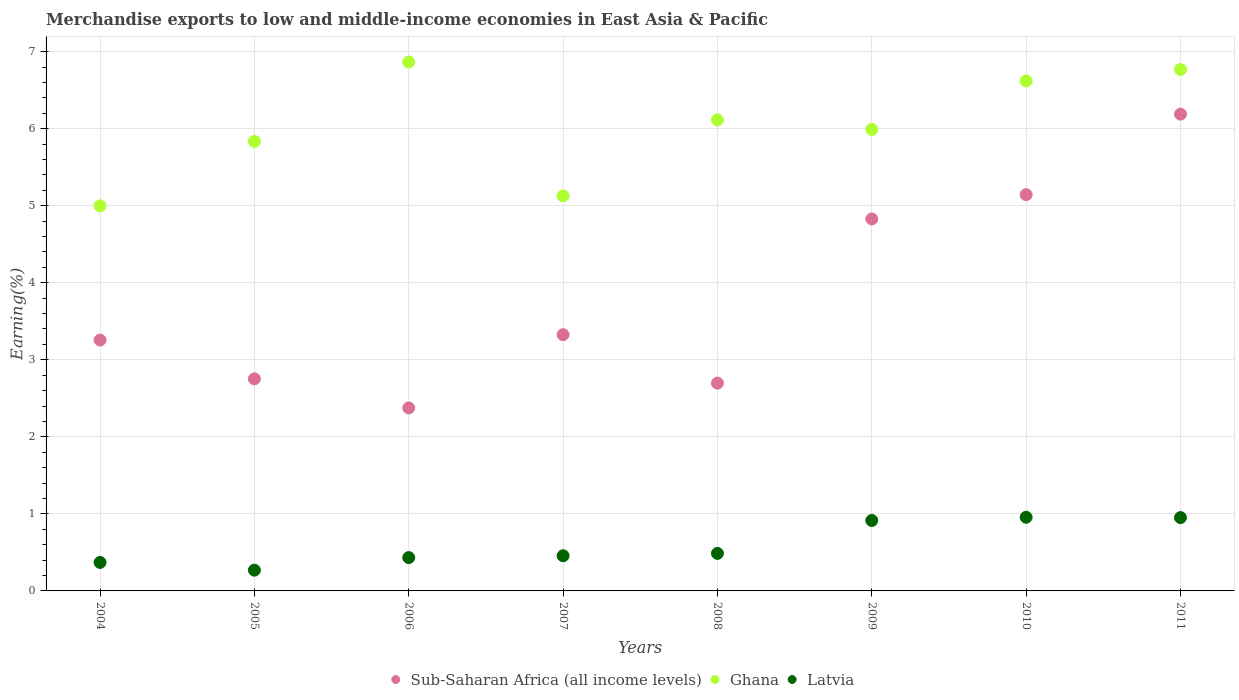What is the percentage of amount earned from merchandise exports in Latvia in 2010?
Offer a terse response. 0.96. Across all years, what is the maximum percentage of amount earned from merchandise exports in Sub-Saharan Africa (all income levels)?
Your answer should be very brief. 6.19. Across all years, what is the minimum percentage of amount earned from merchandise exports in Latvia?
Provide a succinct answer. 0.27. In which year was the percentage of amount earned from merchandise exports in Latvia maximum?
Ensure brevity in your answer.  2010. In which year was the percentage of amount earned from merchandise exports in Latvia minimum?
Make the answer very short. 2005. What is the total percentage of amount earned from merchandise exports in Ghana in the graph?
Provide a short and direct response. 48.32. What is the difference between the percentage of amount earned from merchandise exports in Latvia in 2004 and that in 2011?
Give a very brief answer. -0.58. What is the difference between the percentage of amount earned from merchandise exports in Latvia in 2005 and the percentage of amount earned from merchandise exports in Ghana in 2009?
Provide a succinct answer. -5.72. What is the average percentage of amount earned from merchandise exports in Sub-Saharan Africa (all income levels) per year?
Your answer should be compact. 3.82. In the year 2011, what is the difference between the percentage of amount earned from merchandise exports in Latvia and percentage of amount earned from merchandise exports in Ghana?
Make the answer very short. -5.82. What is the ratio of the percentage of amount earned from merchandise exports in Latvia in 2009 to that in 2010?
Offer a terse response. 0.96. What is the difference between the highest and the second highest percentage of amount earned from merchandise exports in Latvia?
Ensure brevity in your answer.  0. What is the difference between the highest and the lowest percentage of amount earned from merchandise exports in Sub-Saharan Africa (all income levels)?
Keep it short and to the point. 3.81. Is the sum of the percentage of amount earned from merchandise exports in Ghana in 2004 and 2005 greater than the maximum percentage of amount earned from merchandise exports in Sub-Saharan Africa (all income levels) across all years?
Provide a short and direct response. Yes. Is it the case that in every year, the sum of the percentage of amount earned from merchandise exports in Latvia and percentage of amount earned from merchandise exports in Ghana  is greater than the percentage of amount earned from merchandise exports in Sub-Saharan Africa (all income levels)?
Make the answer very short. Yes. Does the percentage of amount earned from merchandise exports in Latvia monotonically increase over the years?
Offer a terse response. No. Is the percentage of amount earned from merchandise exports in Ghana strictly greater than the percentage of amount earned from merchandise exports in Latvia over the years?
Give a very brief answer. Yes. How many dotlines are there?
Make the answer very short. 3. How many years are there in the graph?
Your answer should be very brief. 8. What is the difference between two consecutive major ticks on the Y-axis?
Offer a terse response. 1. Are the values on the major ticks of Y-axis written in scientific E-notation?
Your response must be concise. No. Does the graph contain any zero values?
Provide a short and direct response. No. Where does the legend appear in the graph?
Offer a very short reply. Bottom center. What is the title of the graph?
Ensure brevity in your answer.  Merchandise exports to low and middle-income economies in East Asia & Pacific. Does "Tajikistan" appear as one of the legend labels in the graph?
Provide a short and direct response. No. What is the label or title of the Y-axis?
Provide a short and direct response. Earning(%). What is the Earning(%) of Sub-Saharan Africa (all income levels) in 2004?
Give a very brief answer. 3.26. What is the Earning(%) in Ghana in 2004?
Your response must be concise. 5. What is the Earning(%) of Latvia in 2004?
Give a very brief answer. 0.37. What is the Earning(%) of Sub-Saharan Africa (all income levels) in 2005?
Give a very brief answer. 2.75. What is the Earning(%) of Ghana in 2005?
Provide a succinct answer. 5.83. What is the Earning(%) of Latvia in 2005?
Your answer should be very brief. 0.27. What is the Earning(%) in Sub-Saharan Africa (all income levels) in 2006?
Your response must be concise. 2.38. What is the Earning(%) in Ghana in 2006?
Keep it short and to the point. 6.87. What is the Earning(%) in Latvia in 2006?
Ensure brevity in your answer.  0.43. What is the Earning(%) in Sub-Saharan Africa (all income levels) in 2007?
Make the answer very short. 3.33. What is the Earning(%) in Ghana in 2007?
Provide a short and direct response. 5.13. What is the Earning(%) in Latvia in 2007?
Your response must be concise. 0.46. What is the Earning(%) in Sub-Saharan Africa (all income levels) in 2008?
Your answer should be compact. 2.7. What is the Earning(%) of Ghana in 2008?
Give a very brief answer. 6.12. What is the Earning(%) of Latvia in 2008?
Make the answer very short. 0.49. What is the Earning(%) in Sub-Saharan Africa (all income levels) in 2009?
Your answer should be very brief. 4.83. What is the Earning(%) of Ghana in 2009?
Your answer should be very brief. 5.99. What is the Earning(%) of Latvia in 2009?
Offer a very short reply. 0.91. What is the Earning(%) of Sub-Saharan Africa (all income levels) in 2010?
Your response must be concise. 5.14. What is the Earning(%) in Ghana in 2010?
Your answer should be very brief. 6.62. What is the Earning(%) in Latvia in 2010?
Your answer should be compact. 0.96. What is the Earning(%) of Sub-Saharan Africa (all income levels) in 2011?
Make the answer very short. 6.19. What is the Earning(%) of Ghana in 2011?
Your answer should be very brief. 6.77. What is the Earning(%) of Latvia in 2011?
Give a very brief answer. 0.95. Across all years, what is the maximum Earning(%) in Sub-Saharan Africa (all income levels)?
Provide a short and direct response. 6.19. Across all years, what is the maximum Earning(%) of Ghana?
Your answer should be compact. 6.87. Across all years, what is the maximum Earning(%) of Latvia?
Your answer should be compact. 0.96. Across all years, what is the minimum Earning(%) in Sub-Saharan Africa (all income levels)?
Provide a short and direct response. 2.38. Across all years, what is the minimum Earning(%) of Ghana?
Ensure brevity in your answer.  5. Across all years, what is the minimum Earning(%) in Latvia?
Keep it short and to the point. 0.27. What is the total Earning(%) of Sub-Saharan Africa (all income levels) in the graph?
Your response must be concise. 30.57. What is the total Earning(%) in Ghana in the graph?
Provide a succinct answer. 48.32. What is the total Earning(%) in Latvia in the graph?
Provide a succinct answer. 4.84. What is the difference between the Earning(%) of Sub-Saharan Africa (all income levels) in 2004 and that in 2005?
Provide a short and direct response. 0.5. What is the difference between the Earning(%) in Ghana in 2004 and that in 2005?
Offer a very short reply. -0.84. What is the difference between the Earning(%) in Latvia in 2004 and that in 2005?
Make the answer very short. 0.1. What is the difference between the Earning(%) in Sub-Saharan Africa (all income levels) in 2004 and that in 2006?
Your answer should be very brief. 0.88. What is the difference between the Earning(%) of Ghana in 2004 and that in 2006?
Give a very brief answer. -1.87. What is the difference between the Earning(%) in Latvia in 2004 and that in 2006?
Give a very brief answer. -0.06. What is the difference between the Earning(%) of Sub-Saharan Africa (all income levels) in 2004 and that in 2007?
Provide a short and direct response. -0.07. What is the difference between the Earning(%) of Ghana in 2004 and that in 2007?
Provide a succinct answer. -0.13. What is the difference between the Earning(%) in Latvia in 2004 and that in 2007?
Offer a terse response. -0.09. What is the difference between the Earning(%) of Sub-Saharan Africa (all income levels) in 2004 and that in 2008?
Your answer should be compact. 0.56. What is the difference between the Earning(%) in Ghana in 2004 and that in 2008?
Provide a succinct answer. -1.12. What is the difference between the Earning(%) of Latvia in 2004 and that in 2008?
Offer a terse response. -0.12. What is the difference between the Earning(%) of Sub-Saharan Africa (all income levels) in 2004 and that in 2009?
Your response must be concise. -1.57. What is the difference between the Earning(%) of Ghana in 2004 and that in 2009?
Your answer should be compact. -0.99. What is the difference between the Earning(%) of Latvia in 2004 and that in 2009?
Ensure brevity in your answer.  -0.54. What is the difference between the Earning(%) of Sub-Saharan Africa (all income levels) in 2004 and that in 2010?
Provide a succinct answer. -1.89. What is the difference between the Earning(%) in Ghana in 2004 and that in 2010?
Provide a succinct answer. -1.62. What is the difference between the Earning(%) in Latvia in 2004 and that in 2010?
Give a very brief answer. -0.59. What is the difference between the Earning(%) in Sub-Saharan Africa (all income levels) in 2004 and that in 2011?
Provide a short and direct response. -2.93. What is the difference between the Earning(%) in Ghana in 2004 and that in 2011?
Your answer should be compact. -1.77. What is the difference between the Earning(%) in Latvia in 2004 and that in 2011?
Your answer should be compact. -0.58. What is the difference between the Earning(%) in Sub-Saharan Africa (all income levels) in 2005 and that in 2006?
Make the answer very short. 0.38. What is the difference between the Earning(%) of Ghana in 2005 and that in 2006?
Provide a succinct answer. -1.03. What is the difference between the Earning(%) in Latvia in 2005 and that in 2006?
Your answer should be compact. -0.16. What is the difference between the Earning(%) of Sub-Saharan Africa (all income levels) in 2005 and that in 2007?
Your response must be concise. -0.57. What is the difference between the Earning(%) of Ghana in 2005 and that in 2007?
Ensure brevity in your answer.  0.71. What is the difference between the Earning(%) of Latvia in 2005 and that in 2007?
Keep it short and to the point. -0.19. What is the difference between the Earning(%) of Sub-Saharan Africa (all income levels) in 2005 and that in 2008?
Give a very brief answer. 0.06. What is the difference between the Earning(%) in Ghana in 2005 and that in 2008?
Give a very brief answer. -0.28. What is the difference between the Earning(%) of Latvia in 2005 and that in 2008?
Offer a terse response. -0.22. What is the difference between the Earning(%) in Sub-Saharan Africa (all income levels) in 2005 and that in 2009?
Offer a terse response. -2.08. What is the difference between the Earning(%) in Ghana in 2005 and that in 2009?
Your answer should be very brief. -0.16. What is the difference between the Earning(%) of Latvia in 2005 and that in 2009?
Give a very brief answer. -0.65. What is the difference between the Earning(%) in Sub-Saharan Africa (all income levels) in 2005 and that in 2010?
Keep it short and to the point. -2.39. What is the difference between the Earning(%) of Ghana in 2005 and that in 2010?
Your answer should be compact. -0.79. What is the difference between the Earning(%) of Latvia in 2005 and that in 2010?
Provide a short and direct response. -0.69. What is the difference between the Earning(%) in Sub-Saharan Africa (all income levels) in 2005 and that in 2011?
Your response must be concise. -3.44. What is the difference between the Earning(%) in Ghana in 2005 and that in 2011?
Provide a succinct answer. -0.93. What is the difference between the Earning(%) in Latvia in 2005 and that in 2011?
Provide a succinct answer. -0.68. What is the difference between the Earning(%) of Sub-Saharan Africa (all income levels) in 2006 and that in 2007?
Provide a short and direct response. -0.95. What is the difference between the Earning(%) of Ghana in 2006 and that in 2007?
Offer a very short reply. 1.74. What is the difference between the Earning(%) of Latvia in 2006 and that in 2007?
Keep it short and to the point. -0.02. What is the difference between the Earning(%) in Sub-Saharan Africa (all income levels) in 2006 and that in 2008?
Your response must be concise. -0.32. What is the difference between the Earning(%) of Ghana in 2006 and that in 2008?
Provide a short and direct response. 0.75. What is the difference between the Earning(%) of Latvia in 2006 and that in 2008?
Keep it short and to the point. -0.05. What is the difference between the Earning(%) in Sub-Saharan Africa (all income levels) in 2006 and that in 2009?
Your response must be concise. -2.45. What is the difference between the Earning(%) in Ghana in 2006 and that in 2009?
Give a very brief answer. 0.88. What is the difference between the Earning(%) of Latvia in 2006 and that in 2009?
Offer a very short reply. -0.48. What is the difference between the Earning(%) in Sub-Saharan Africa (all income levels) in 2006 and that in 2010?
Give a very brief answer. -2.77. What is the difference between the Earning(%) of Ghana in 2006 and that in 2010?
Keep it short and to the point. 0.25. What is the difference between the Earning(%) of Latvia in 2006 and that in 2010?
Provide a short and direct response. -0.52. What is the difference between the Earning(%) in Sub-Saharan Africa (all income levels) in 2006 and that in 2011?
Offer a very short reply. -3.81. What is the difference between the Earning(%) of Ghana in 2006 and that in 2011?
Your answer should be very brief. 0.1. What is the difference between the Earning(%) in Latvia in 2006 and that in 2011?
Provide a short and direct response. -0.52. What is the difference between the Earning(%) in Sub-Saharan Africa (all income levels) in 2007 and that in 2008?
Give a very brief answer. 0.63. What is the difference between the Earning(%) in Ghana in 2007 and that in 2008?
Offer a terse response. -0.99. What is the difference between the Earning(%) of Latvia in 2007 and that in 2008?
Your response must be concise. -0.03. What is the difference between the Earning(%) in Sub-Saharan Africa (all income levels) in 2007 and that in 2009?
Your response must be concise. -1.5. What is the difference between the Earning(%) in Ghana in 2007 and that in 2009?
Your answer should be compact. -0.86. What is the difference between the Earning(%) in Latvia in 2007 and that in 2009?
Offer a very short reply. -0.46. What is the difference between the Earning(%) of Sub-Saharan Africa (all income levels) in 2007 and that in 2010?
Your answer should be compact. -1.82. What is the difference between the Earning(%) in Ghana in 2007 and that in 2010?
Provide a short and direct response. -1.49. What is the difference between the Earning(%) in Latvia in 2007 and that in 2010?
Your answer should be compact. -0.5. What is the difference between the Earning(%) in Sub-Saharan Africa (all income levels) in 2007 and that in 2011?
Ensure brevity in your answer.  -2.86. What is the difference between the Earning(%) in Ghana in 2007 and that in 2011?
Keep it short and to the point. -1.64. What is the difference between the Earning(%) in Latvia in 2007 and that in 2011?
Keep it short and to the point. -0.5. What is the difference between the Earning(%) in Sub-Saharan Africa (all income levels) in 2008 and that in 2009?
Provide a succinct answer. -2.13. What is the difference between the Earning(%) of Ghana in 2008 and that in 2009?
Your answer should be compact. 0.12. What is the difference between the Earning(%) in Latvia in 2008 and that in 2009?
Provide a short and direct response. -0.43. What is the difference between the Earning(%) of Sub-Saharan Africa (all income levels) in 2008 and that in 2010?
Ensure brevity in your answer.  -2.45. What is the difference between the Earning(%) in Ghana in 2008 and that in 2010?
Ensure brevity in your answer.  -0.5. What is the difference between the Earning(%) of Latvia in 2008 and that in 2010?
Keep it short and to the point. -0.47. What is the difference between the Earning(%) of Sub-Saharan Africa (all income levels) in 2008 and that in 2011?
Make the answer very short. -3.49. What is the difference between the Earning(%) of Ghana in 2008 and that in 2011?
Offer a very short reply. -0.65. What is the difference between the Earning(%) in Latvia in 2008 and that in 2011?
Offer a terse response. -0.46. What is the difference between the Earning(%) in Sub-Saharan Africa (all income levels) in 2009 and that in 2010?
Offer a terse response. -0.32. What is the difference between the Earning(%) of Ghana in 2009 and that in 2010?
Provide a short and direct response. -0.63. What is the difference between the Earning(%) in Latvia in 2009 and that in 2010?
Give a very brief answer. -0.04. What is the difference between the Earning(%) of Sub-Saharan Africa (all income levels) in 2009 and that in 2011?
Keep it short and to the point. -1.36. What is the difference between the Earning(%) of Ghana in 2009 and that in 2011?
Your response must be concise. -0.78. What is the difference between the Earning(%) in Latvia in 2009 and that in 2011?
Ensure brevity in your answer.  -0.04. What is the difference between the Earning(%) of Sub-Saharan Africa (all income levels) in 2010 and that in 2011?
Offer a terse response. -1.05. What is the difference between the Earning(%) in Ghana in 2010 and that in 2011?
Keep it short and to the point. -0.15. What is the difference between the Earning(%) in Latvia in 2010 and that in 2011?
Give a very brief answer. 0. What is the difference between the Earning(%) of Sub-Saharan Africa (all income levels) in 2004 and the Earning(%) of Ghana in 2005?
Provide a succinct answer. -2.58. What is the difference between the Earning(%) in Sub-Saharan Africa (all income levels) in 2004 and the Earning(%) in Latvia in 2005?
Your answer should be very brief. 2.99. What is the difference between the Earning(%) of Ghana in 2004 and the Earning(%) of Latvia in 2005?
Provide a succinct answer. 4.73. What is the difference between the Earning(%) in Sub-Saharan Africa (all income levels) in 2004 and the Earning(%) in Ghana in 2006?
Your response must be concise. -3.61. What is the difference between the Earning(%) in Sub-Saharan Africa (all income levels) in 2004 and the Earning(%) in Latvia in 2006?
Offer a very short reply. 2.82. What is the difference between the Earning(%) in Ghana in 2004 and the Earning(%) in Latvia in 2006?
Your answer should be very brief. 4.57. What is the difference between the Earning(%) of Sub-Saharan Africa (all income levels) in 2004 and the Earning(%) of Ghana in 2007?
Your answer should be compact. -1.87. What is the difference between the Earning(%) in Sub-Saharan Africa (all income levels) in 2004 and the Earning(%) in Latvia in 2007?
Your answer should be compact. 2.8. What is the difference between the Earning(%) in Ghana in 2004 and the Earning(%) in Latvia in 2007?
Your response must be concise. 4.54. What is the difference between the Earning(%) of Sub-Saharan Africa (all income levels) in 2004 and the Earning(%) of Ghana in 2008?
Your answer should be very brief. -2.86. What is the difference between the Earning(%) of Sub-Saharan Africa (all income levels) in 2004 and the Earning(%) of Latvia in 2008?
Give a very brief answer. 2.77. What is the difference between the Earning(%) in Ghana in 2004 and the Earning(%) in Latvia in 2008?
Offer a terse response. 4.51. What is the difference between the Earning(%) in Sub-Saharan Africa (all income levels) in 2004 and the Earning(%) in Ghana in 2009?
Your answer should be very brief. -2.73. What is the difference between the Earning(%) in Sub-Saharan Africa (all income levels) in 2004 and the Earning(%) in Latvia in 2009?
Your answer should be compact. 2.34. What is the difference between the Earning(%) of Ghana in 2004 and the Earning(%) of Latvia in 2009?
Make the answer very short. 4.08. What is the difference between the Earning(%) of Sub-Saharan Africa (all income levels) in 2004 and the Earning(%) of Ghana in 2010?
Ensure brevity in your answer.  -3.36. What is the difference between the Earning(%) in Sub-Saharan Africa (all income levels) in 2004 and the Earning(%) in Latvia in 2010?
Provide a succinct answer. 2.3. What is the difference between the Earning(%) in Ghana in 2004 and the Earning(%) in Latvia in 2010?
Your answer should be very brief. 4.04. What is the difference between the Earning(%) of Sub-Saharan Africa (all income levels) in 2004 and the Earning(%) of Ghana in 2011?
Your response must be concise. -3.51. What is the difference between the Earning(%) in Sub-Saharan Africa (all income levels) in 2004 and the Earning(%) in Latvia in 2011?
Your answer should be compact. 2.3. What is the difference between the Earning(%) of Ghana in 2004 and the Earning(%) of Latvia in 2011?
Make the answer very short. 4.05. What is the difference between the Earning(%) of Sub-Saharan Africa (all income levels) in 2005 and the Earning(%) of Ghana in 2006?
Provide a short and direct response. -4.11. What is the difference between the Earning(%) of Sub-Saharan Africa (all income levels) in 2005 and the Earning(%) of Latvia in 2006?
Ensure brevity in your answer.  2.32. What is the difference between the Earning(%) of Ghana in 2005 and the Earning(%) of Latvia in 2006?
Your answer should be very brief. 5.4. What is the difference between the Earning(%) of Sub-Saharan Africa (all income levels) in 2005 and the Earning(%) of Ghana in 2007?
Provide a short and direct response. -2.37. What is the difference between the Earning(%) in Sub-Saharan Africa (all income levels) in 2005 and the Earning(%) in Latvia in 2007?
Offer a very short reply. 2.3. What is the difference between the Earning(%) in Ghana in 2005 and the Earning(%) in Latvia in 2007?
Ensure brevity in your answer.  5.38. What is the difference between the Earning(%) of Sub-Saharan Africa (all income levels) in 2005 and the Earning(%) of Ghana in 2008?
Your answer should be very brief. -3.36. What is the difference between the Earning(%) in Sub-Saharan Africa (all income levels) in 2005 and the Earning(%) in Latvia in 2008?
Make the answer very short. 2.27. What is the difference between the Earning(%) in Ghana in 2005 and the Earning(%) in Latvia in 2008?
Give a very brief answer. 5.35. What is the difference between the Earning(%) of Sub-Saharan Africa (all income levels) in 2005 and the Earning(%) of Ghana in 2009?
Offer a very short reply. -3.24. What is the difference between the Earning(%) of Sub-Saharan Africa (all income levels) in 2005 and the Earning(%) of Latvia in 2009?
Provide a short and direct response. 1.84. What is the difference between the Earning(%) of Ghana in 2005 and the Earning(%) of Latvia in 2009?
Offer a terse response. 4.92. What is the difference between the Earning(%) in Sub-Saharan Africa (all income levels) in 2005 and the Earning(%) in Ghana in 2010?
Ensure brevity in your answer.  -3.87. What is the difference between the Earning(%) of Sub-Saharan Africa (all income levels) in 2005 and the Earning(%) of Latvia in 2010?
Provide a short and direct response. 1.8. What is the difference between the Earning(%) in Ghana in 2005 and the Earning(%) in Latvia in 2010?
Give a very brief answer. 4.88. What is the difference between the Earning(%) of Sub-Saharan Africa (all income levels) in 2005 and the Earning(%) of Ghana in 2011?
Provide a short and direct response. -4.01. What is the difference between the Earning(%) in Sub-Saharan Africa (all income levels) in 2005 and the Earning(%) in Latvia in 2011?
Offer a very short reply. 1.8. What is the difference between the Earning(%) in Ghana in 2005 and the Earning(%) in Latvia in 2011?
Provide a succinct answer. 4.88. What is the difference between the Earning(%) in Sub-Saharan Africa (all income levels) in 2006 and the Earning(%) in Ghana in 2007?
Your response must be concise. -2.75. What is the difference between the Earning(%) in Sub-Saharan Africa (all income levels) in 2006 and the Earning(%) in Latvia in 2007?
Provide a short and direct response. 1.92. What is the difference between the Earning(%) of Ghana in 2006 and the Earning(%) of Latvia in 2007?
Your answer should be compact. 6.41. What is the difference between the Earning(%) in Sub-Saharan Africa (all income levels) in 2006 and the Earning(%) in Ghana in 2008?
Your answer should be compact. -3.74. What is the difference between the Earning(%) of Sub-Saharan Africa (all income levels) in 2006 and the Earning(%) of Latvia in 2008?
Keep it short and to the point. 1.89. What is the difference between the Earning(%) of Ghana in 2006 and the Earning(%) of Latvia in 2008?
Your answer should be compact. 6.38. What is the difference between the Earning(%) in Sub-Saharan Africa (all income levels) in 2006 and the Earning(%) in Ghana in 2009?
Give a very brief answer. -3.62. What is the difference between the Earning(%) in Sub-Saharan Africa (all income levels) in 2006 and the Earning(%) in Latvia in 2009?
Make the answer very short. 1.46. What is the difference between the Earning(%) in Ghana in 2006 and the Earning(%) in Latvia in 2009?
Your answer should be very brief. 5.95. What is the difference between the Earning(%) in Sub-Saharan Africa (all income levels) in 2006 and the Earning(%) in Ghana in 2010?
Offer a very short reply. -4.24. What is the difference between the Earning(%) in Sub-Saharan Africa (all income levels) in 2006 and the Earning(%) in Latvia in 2010?
Make the answer very short. 1.42. What is the difference between the Earning(%) of Ghana in 2006 and the Earning(%) of Latvia in 2010?
Keep it short and to the point. 5.91. What is the difference between the Earning(%) of Sub-Saharan Africa (all income levels) in 2006 and the Earning(%) of Ghana in 2011?
Ensure brevity in your answer.  -4.39. What is the difference between the Earning(%) in Sub-Saharan Africa (all income levels) in 2006 and the Earning(%) in Latvia in 2011?
Make the answer very short. 1.42. What is the difference between the Earning(%) in Ghana in 2006 and the Earning(%) in Latvia in 2011?
Your response must be concise. 5.91. What is the difference between the Earning(%) in Sub-Saharan Africa (all income levels) in 2007 and the Earning(%) in Ghana in 2008?
Your answer should be compact. -2.79. What is the difference between the Earning(%) in Sub-Saharan Africa (all income levels) in 2007 and the Earning(%) in Latvia in 2008?
Offer a very short reply. 2.84. What is the difference between the Earning(%) in Ghana in 2007 and the Earning(%) in Latvia in 2008?
Offer a terse response. 4.64. What is the difference between the Earning(%) of Sub-Saharan Africa (all income levels) in 2007 and the Earning(%) of Ghana in 2009?
Your response must be concise. -2.66. What is the difference between the Earning(%) of Sub-Saharan Africa (all income levels) in 2007 and the Earning(%) of Latvia in 2009?
Keep it short and to the point. 2.41. What is the difference between the Earning(%) in Ghana in 2007 and the Earning(%) in Latvia in 2009?
Your answer should be compact. 4.21. What is the difference between the Earning(%) in Sub-Saharan Africa (all income levels) in 2007 and the Earning(%) in Ghana in 2010?
Your answer should be compact. -3.29. What is the difference between the Earning(%) in Sub-Saharan Africa (all income levels) in 2007 and the Earning(%) in Latvia in 2010?
Your answer should be compact. 2.37. What is the difference between the Earning(%) of Ghana in 2007 and the Earning(%) of Latvia in 2010?
Ensure brevity in your answer.  4.17. What is the difference between the Earning(%) of Sub-Saharan Africa (all income levels) in 2007 and the Earning(%) of Ghana in 2011?
Offer a very short reply. -3.44. What is the difference between the Earning(%) of Sub-Saharan Africa (all income levels) in 2007 and the Earning(%) of Latvia in 2011?
Make the answer very short. 2.37. What is the difference between the Earning(%) in Ghana in 2007 and the Earning(%) in Latvia in 2011?
Give a very brief answer. 4.18. What is the difference between the Earning(%) of Sub-Saharan Africa (all income levels) in 2008 and the Earning(%) of Ghana in 2009?
Keep it short and to the point. -3.29. What is the difference between the Earning(%) in Sub-Saharan Africa (all income levels) in 2008 and the Earning(%) in Latvia in 2009?
Provide a short and direct response. 1.78. What is the difference between the Earning(%) in Ghana in 2008 and the Earning(%) in Latvia in 2009?
Your answer should be compact. 5.2. What is the difference between the Earning(%) in Sub-Saharan Africa (all income levels) in 2008 and the Earning(%) in Ghana in 2010?
Ensure brevity in your answer.  -3.92. What is the difference between the Earning(%) in Sub-Saharan Africa (all income levels) in 2008 and the Earning(%) in Latvia in 2010?
Your answer should be compact. 1.74. What is the difference between the Earning(%) in Ghana in 2008 and the Earning(%) in Latvia in 2010?
Your answer should be compact. 5.16. What is the difference between the Earning(%) in Sub-Saharan Africa (all income levels) in 2008 and the Earning(%) in Ghana in 2011?
Keep it short and to the point. -4.07. What is the difference between the Earning(%) in Sub-Saharan Africa (all income levels) in 2008 and the Earning(%) in Latvia in 2011?
Provide a short and direct response. 1.75. What is the difference between the Earning(%) of Ghana in 2008 and the Earning(%) of Latvia in 2011?
Keep it short and to the point. 5.16. What is the difference between the Earning(%) in Sub-Saharan Africa (all income levels) in 2009 and the Earning(%) in Ghana in 2010?
Your response must be concise. -1.79. What is the difference between the Earning(%) of Sub-Saharan Africa (all income levels) in 2009 and the Earning(%) of Latvia in 2010?
Give a very brief answer. 3.87. What is the difference between the Earning(%) of Ghana in 2009 and the Earning(%) of Latvia in 2010?
Offer a terse response. 5.03. What is the difference between the Earning(%) of Sub-Saharan Africa (all income levels) in 2009 and the Earning(%) of Ghana in 2011?
Keep it short and to the point. -1.94. What is the difference between the Earning(%) in Sub-Saharan Africa (all income levels) in 2009 and the Earning(%) in Latvia in 2011?
Provide a succinct answer. 3.88. What is the difference between the Earning(%) of Ghana in 2009 and the Earning(%) of Latvia in 2011?
Offer a terse response. 5.04. What is the difference between the Earning(%) of Sub-Saharan Africa (all income levels) in 2010 and the Earning(%) of Ghana in 2011?
Your response must be concise. -1.62. What is the difference between the Earning(%) in Sub-Saharan Africa (all income levels) in 2010 and the Earning(%) in Latvia in 2011?
Provide a succinct answer. 4.19. What is the difference between the Earning(%) of Ghana in 2010 and the Earning(%) of Latvia in 2011?
Your response must be concise. 5.67. What is the average Earning(%) of Sub-Saharan Africa (all income levels) per year?
Offer a terse response. 3.82. What is the average Earning(%) of Ghana per year?
Provide a succinct answer. 6.04. What is the average Earning(%) in Latvia per year?
Offer a very short reply. 0.6. In the year 2004, what is the difference between the Earning(%) in Sub-Saharan Africa (all income levels) and Earning(%) in Ghana?
Keep it short and to the point. -1.74. In the year 2004, what is the difference between the Earning(%) in Sub-Saharan Africa (all income levels) and Earning(%) in Latvia?
Offer a very short reply. 2.89. In the year 2004, what is the difference between the Earning(%) in Ghana and Earning(%) in Latvia?
Offer a very short reply. 4.63. In the year 2005, what is the difference between the Earning(%) in Sub-Saharan Africa (all income levels) and Earning(%) in Ghana?
Offer a terse response. -3.08. In the year 2005, what is the difference between the Earning(%) of Sub-Saharan Africa (all income levels) and Earning(%) of Latvia?
Keep it short and to the point. 2.48. In the year 2005, what is the difference between the Earning(%) of Ghana and Earning(%) of Latvia?
Give a very brief answer. 5.57. In the year 2006, what is the difference between the Earning(%) of Sub-Saharan Africa (all income levels) and Earning(%) of Ghana?
Your answer should be very brief. -4.49. In the year 2006, what is the difference between the Earning(%) of Sub-Saharan Africa (all income levels) and Earning(%) of Latvia?
Provide a short and direct response. 1.94. In the year 2006, what is the difference between the Earning(%) in Ghana and Earning(%) in Latvia?
Ensure brevity in your answer.  6.43. In the year 2007, what is the difference between the Earning(%) in Sub-Saharan Africa (all income levels) and Earning(%) in Ghana?
Ensure brevity in your answer.  -1.8. In the year 2007, what is the difference between the Earning(%) of Sub-Saharan Africa (all income levels) and Earning(%) of Latvia?
Ensure brevity in your answer.  2.87. In the year 2007, what is the difference between the Earning(%) of Ghana and Earning(%) of Latvia?
Make the answer very short. 4.67. In the year 2008, what is the difference between the Earning(%) of Sub-Saharan Africa (all income levels) and Earning(%) of Ghana?
Your response must be concise. -3.42. In the year 2008, what is the difference between the Earning(%) of Sub-Saharan Africa (all income levels) and Earning(%) of Latvia?
Provide a succinct answer. 2.21. In the year 2008, what is the difference between the Earning(%) of Ghana and Earning(%) of Latvia?
Your response must be concise. 5.63. In the year 2009, what is the difference between the Earning(%) of Sub-Saharan Africa (all income levels) and Earning(%) of Ghana?
Your response must be concise. -1.16. In the year 2009, what is the difference between the Earning(%) of Sub-Saharan Africa (all income levels) and Earning(%) of Latvia?
Keep it short and to the point. 3.91. In the year 2009, what is the difference between the Earning(%) in Ghana and Earning(%) in Latvia?
Offer a terse response. 5.08. In the year 2010, what is the difference between the Earning(%) in Sub-Saharan Africa (all income levels) and Earning(%) in Ghana?
Ensure brevity in your answer.  -1.48. In the year 2010, what is the difference between the Earning(%) in Sub-Saharan Africa (all income levels) and Earning(%) in Latvia?
Provide a short and direct response. 4.19. In the year 2010, what is the difference between the Earning(%) in Ghana and Earning(%) in Latvia?
Offer a terse response. 5.66. In the year 2011, what is the difference between the Earning(%) of Sub-Saharan Africa (all income levels) and Earning(%) of Ghana?
Offer a very short reply. -0.58. In the year 2011, what is the difference between the Earning(%) of Sub-Saharan Africa (all income levels) and Earning(%) of Latvia?
Ensure brevity in your answer.  5.24. In the year 2011, what is the difference between the Earning(%) of Ghana and Earning(%) of Latvia?
Offer a terse response. 5.82. What is the ratio of the Earning(%) of Sub-Saharan Africa (all income levels) in 2004 to that in 2005?
Offer a terse response. 1.18. What is the ratio of the Earning(%) in Ghana in 2004 to that in 2005?
Your response must be concise. 0.86. What is the ratio of the Earning(%) of Latvia in 2004 to that in 2005?
Provide a short and direct response. 1.37. What is the ratio of the Earning(%) of Sub-Saharan Africa (all income levels) in 2004 to that in 2006?
Your response must be concise. 1.37. What is the ratio of the Earning(%) in Ghana in 2004 to that in 2006?
Keep it short and to the point. 0.73. What is the ratio of the Earning(%) of Latvia in 2004 to that in 2006?
Your response must be concise. 0.85. What is the ratio of the Earning(%) in Sub-Saharan Africa (all income levels) in 2004 to that in 2007?
Provide a short and direct response. 0.98. What is the ratio of the Earning(%) of Ghana in 2004 to that in 2007?
Offer a very short reply. 0.97. What is the ratio of the Earning(%) in Latvia in 2004 to that in 2007?
Your answer should be compact. 0.81. What is the ratio of the Earning(%) of Sub-Saharan Africa (all income levels) in 2004 to that in 2008?
Your answer should be compact. 1.21. What is the ratio of the Earning(%) of Ghana in 2004 to that in 2008?
Your answer should be very brief. 0.82. What is the ratio of the Earning(%) of Latvia in 2004 to that in 2008?
Offer a terse response. 0.76. What is the ratio of the Earning(%) of Sub-Saharan Africa (all income levels) in 2004 to that in 2009?
Your response must be concise. 0.67. What is the ratio of the Earning(%) of Ghana in 2004 to that in 2009?
Your answer should be compact. 0.83. What is the ratio of the Earning(%) in Latvia in 2004 to that in 2009?
Give a very brief answer. 0.4. What is the ratio of the Earning(%) in Sub-Saharan Africa (all income levels) in 2004 to that in 2010?
Ensure brevity in your answer.  0.63. What is the ratio of the Earning(%) in Ghana in 2004 to that in 2010?
Provide a short and direct response. 0.76. What is the ratio of the Earning(%) of Latvia in 2004 to that in 2010?
Provide a succinct answer. 0.39. What is the ratio of the Earning(%) of Sub-Saharan Africa (all income levels) in 2004 to that in 2011?
Your answer should be very brief. 0.53. What is the ratio of the Earning(%) in Ghana in 2004 to that in 2011?
Your answer should be compact. 0.74. What is the ratio of the Earning(%) in Latvia in 2004 to that in 2011?
Keep it short and to the point. 0.39. What is the ratio of the Earning(%) of Sub-Saharan Africa (all income levels) in 2005 to that in 2006?
Your response must be concise. 1.16. What is the ratio of the Earning(%) of Ghana in 2005 to that in 2006?
Your answer should be compact. 0.85. What is the ratio of the Earning(%) in Latvia in 2005 to that in 2006?
Your response must be concise. 0.62. What is the ratio of the Earning(%) in Sub-Saharan Africa (all income levels) in 2005 to that in 2007?
Offer a very short reply. 0.83. What is the ratio of the Earning(%) of Ghana in 2005 to that in 2007?
Offer a very short reply. 1.14. What is the ratio of the Earning(%) of Latvia in 2005 to that in 2007?
Keep it short and to the point. 0.59. What is the ratio of the Earning(%) in Sub-Saharan Africa (all income levels) in 2005 to that in 2008?
Provide a short and direct response. 1.02. What is the ratio of the Earning(%) in Ghana in 2005 to that in 2008?
Ensure brevity in your answer.  0.95. What is the ratio of the Earning(%) of Latvia in 2005 to that in 2008?
Offer a terse response. 0.55. What is the ratio of the Earning(%) in Sub-Saharan Africa (all income levels) in 2005 to that in 2009?
Provide a succinct answer. 0.57. What is the ratio of the Earning(%) of Latvia in 2005 to that in 2009?
Ensure brevity in your answer.  0.29. What is the ratio of the Earning(%) in Sub-Saharan Africa (all income levels) in 2005 to that in 2010?
Provide a succinct answer. 0.54. What is the ratio of the Earning(%) in Ghana in 2005 to that in 2010?
Give a very brief answer. 0.88. What is the ratio of the Earning(%) in Latvia in 2005 to that in 2010?
Keep it short and to the point. 0.28. What is the ratio of the Earning(%) of Sub-Saharan Africa (all income levels) in 2005 to that in 2011?
Ensure brevity in your answer.  0.44. What is the ratio of the Earning(%) in Ghana in 2005 to that in 2011?
Provide a succinct answer. 0.86. What is the ratio of the Earning(%) in Latvia in 2005 to that in 2011?
Provide a short and direct response. 0.28. What is the ratio of the Earning(%) in Sub-Saharan Africa (all income levels) in 2006 to that in 2007?
Give a very brief answer. 0.71. What is the ratio of the Earning(%) in Ghana in 2006 to that in 2007?
Make the answer very short. 1.34. What is the ratio of the Earning(%) of Latvia in 2006 to that in 2007?
Your answer should be compact. 0.95. What is the ratio of the Earning(%) of Sub-Saharan Africa (all income levels) in 2006 to that in 2008?
Your answer should be compact. 0.88. What is the ratio of the Earning(%) in Ghana in 2006 to that in 2008?
Your answer should be compact. 1.12. What is the ratio of the Earning(%) in Latvia in 2006 to that in 2008?
Make the answer very short. 0.89. What is the ratio of the Earning(%) in Sub-Saharan Africa (all income levels) in 2006 to that in 2009?
Your response must be concise. 0.49. What is the ratio of the Earning(%) of Ghana in 2006 to that in 2009?
Your answer should be compact. 1.15. What is the ratio of the Earning(%) of Latvia in 2006 to that in 2009?
Make the answer very short. 0.47. What is the ratio of the Earning(%) of Sub-Saharan Africa (all income levels) in 2006 to that in 2010?
Provide a short and direct response. 0.46. What is the ratio of the Earning(%) of Ghana in 2006 to that in 2010?
Your response must be concise. 1.04. What is the ratio of the Earning(%) in Latvia in 2006 to that in 2010?
Provide a short and direct response. 0.45. What is the ratio of the Earning(%) in Sub-Saharan Africa (all income levels) in 2006 to that in 2011?
Offer a terse response. 0.38. What is the ratio of the Earning(%) in Ghana in 2006 to that in 2011?
Your answer should be compact. 1.01. What is the ratio of the Earning(%) in Latvia in 2006 to that in 2011?
Your response must be concise. 0.45. What is the ratio of the Earning(%) of Sub-Saharan Africa (all income levels) in 2007 to that in 2008?
Make the answer very short. 1.23. What is the ratio of the Earning(%) in Ghana in 2007 to that in 2008?
Your response must be concise. 0.84. What is the ratio of the Earning(%) of Latvia in 2007 to that in 2008?
Provide a succinct answer. 0.94. What is the ratio of the Earning(%) of Sub-Saharan Africa (all income levels) in 2007 to that in 2009?
Provide a short and direct response. 0.69. What is the ratio of the Earning(%) of Ghana in 2007 to that in 2009?
Keep it short and to the point. 0.86. What is the ratio of the Earning(%) of Latvia in 2007 to that in 2009?
Offer a terse response. 0.5. What is the ratio of the Earning(%) in Sub-Saharan Africa (all income levels) in 2007 to that in 2010?
Offer a terse response. 0.65. What is the ratio of the Earning(%) in Ghana in 2007 to that in 2010?
Your response must be concise. 0.77. What is the ratio of the Earning(%) of Latvia in 2007 to that in 2010?
Keep it short and to the point. 0.48. What is the ratio of the Earning(%) in Sub-Saharan Africa (all income levels) in 2007 to that in 2011?
Your answer should be compact. 0.54. What is the ratio of the Earning(%) in Ghana in 2007 to that in 2011?
Ensure brevity in your answer.  0.76. What is the ratio of the Earning(%) of Latvia in 2007 to that in 2011?
Ensure brevity in your answer.  0.48. What is the ratio of the Earning(%) in Sub-Saharan Africa (all income levels) in 2008 to that in 2009?
Ensure brevity in your answer.  0.56. What is the ratio of the Earning(%) in Ghana in 2008 to that in 2009?
Provide a succinct answer. 1.02. What is the ratio of the Earning(%) of Latvia in 2008 to that in 2009?
Provide a succinct answer. 0.53. What is the ratio of the Earning(%) of Sub-Saharan Africa (all income levels) in 2008 to that in 2010?
Provide a short and direct response. 0.52. What is the ratio of the Earning(%) of Ghana in 2008 to that in 2010?
Your answer should be very brief. 0.92. What is the ratio of the Earning(%) in Latvia in 2008 to that in 2010?
Provide a short and direct response. 0.51. What is the ratio of the Earning(%) of Sub-Saharan Africa (all income levels) in 2008 to that in 2011?
Provide a succinct answer. 0.44. What is the ratio of the Earning(%) of Ghana in 2008 to that in 2011?
Keep it short and to the point. 0.9. What is the ratio of the Earning(%) of Latvia in 2008 to that in 2011?
Offer a terse response. 0.51. What is the ratio of the Earning(%) of Sub-Saharan Africa (all income levels) in 2009 to that in 2010?
Your answer should be very brief. 0.94. What is the ratio of the Earning(%) of Ghana in 2009 to that in 2010?
Provide a succinct answer. 0.91. What is the ratio of the Earning(%) in Latvia in 2009 to that in 2010?
Keep it short and to the point. 0.96. What is the ratio of the Earning(%) of Sub-Saharan Africa (all income levels) in 2009 to that in 2011?
Give a very brief answer. 0.78. What is the ratio of the Earning(%) of Ghana in 2009 to that in 2011?
Make the answer very short. 0.89. What is the ratio of the Earning(%) in Latvia in 2009 to that in 2011?
Your response must be concise. 0.96. What is the ratio of the Earning(%) in Sub-Saharan Africa (all income levels) in 2010 to that in 2011?
Make the answer very short. 0.83. What is the ratio of the Earning(%) in Ghana in 2010 to that in 2011?
Keep it short and to the point. 0.98. What is the ratio of the Earning(%) in Latvia in 2010 to that in 2011?
Provide a succinct answer. 1. What is the difference between the highest and the second highest Earning(%) in Sub-Saharan Africa (all income levels)?
Keep it short and to the point. 1.05. What is the difference between the highest and the second highest Earning(%) in Ghana?
Your response must be concise. 0.1. What is the difference between the highest and the second highest Earning(%) of Latvia?
Your answer should be compact. 0. What is the difference between the highest and the lowest Earning(%) in Sub-Saharan Africa (all income levels)?
Your answer should be very brief. 3.81. What is the difference between the highest and the lowest Earning(%) in Ghana?
Provide a succinct answer. 1.87. What is the difference between the highest and the lowest Earning(%) in Latvia?
Your answer should be very brief. 0.69. 